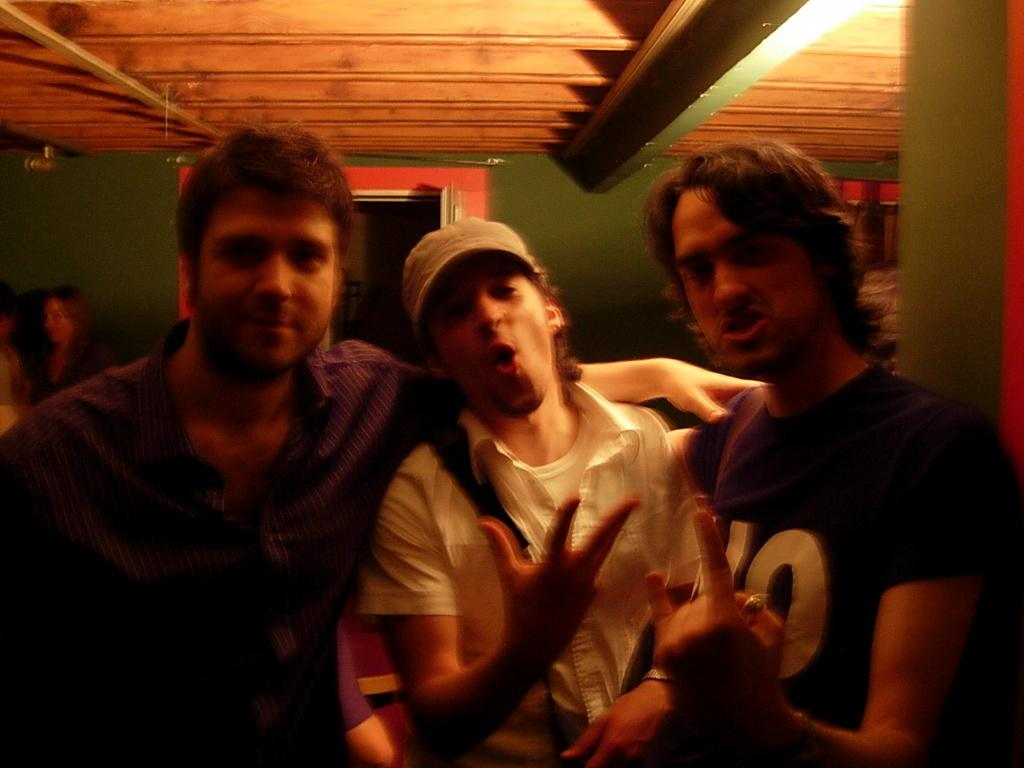What type of structure can be seen in the image? There is a wall in the image. Is there any entrance visible in the image? Yes, there is a door in the image. What can be seen illuminating the area in the image? There are lights in the image. How many people are standing in the front of the image? There are three people standing in the front of the image. Can you describe the overall lighting condition of the image? The image is a little dark. Reasoning: Let's think step by identifying the main subjects and objects in the image based on the provided facts. We then formulate questions that focus on the location and characteristics of these subjects and objects, ensuring that each question can be answered definitively with the information given. We avoid yes/no questions and ensure that the language is simple and clear. Absurd Question/Answer: What type of cemetery can be seen in the image? There is no cemetery present in the image. What is the purpose of the hall in the image? There is no hall mentioned in the facts provided, so we cannot answer a question about a hall in the image. How many copies of the same image are present in the image? There is no indication of multiple copies of the image within the image itself. What type of cemetery can be seen in the image? There is no cemetery present in the image. What is the purpose of the hall in the image? There is no hall mentioned in the facts provided, so we cannot answer a question about a hall in the image. How many copies of the same image are present in the image? There is no indication of multiple copies of the image within the image itself. 